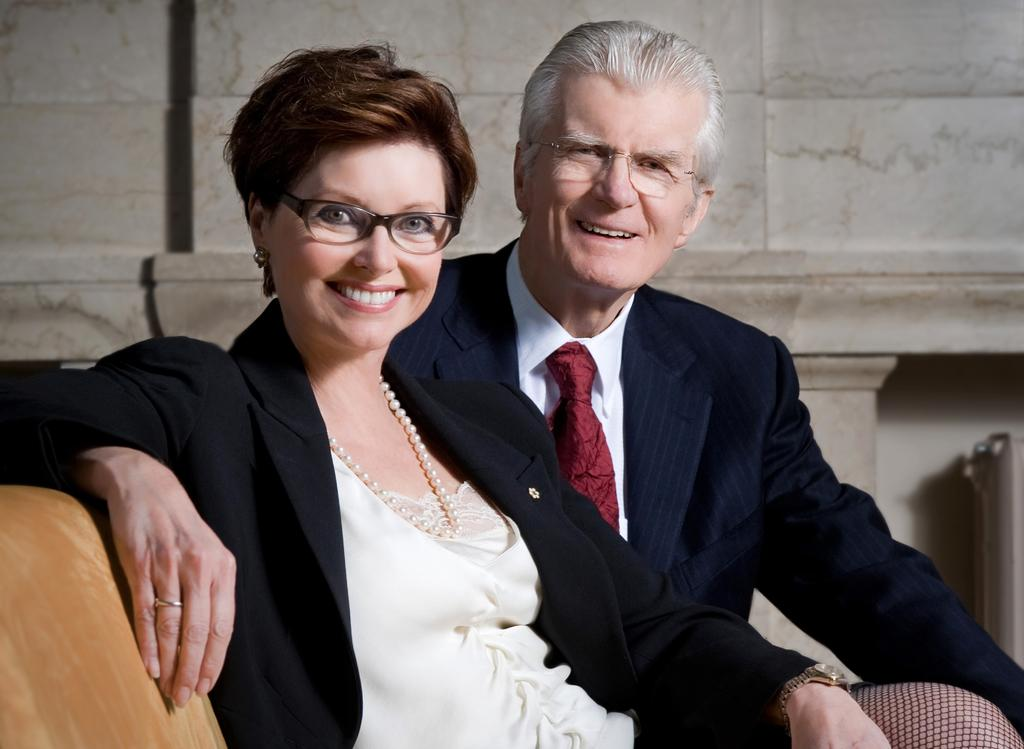Who is present in the image? There is a man and a woman in the image. What are the man and woman doing in the image? Both the man and woman are sitting on a sofa. What can be seen behind the man and woman? There is a wall visible in the image. What is the woman's reaction to the man's cough in the image? There is no cough or reaction to a cough present in the image. 